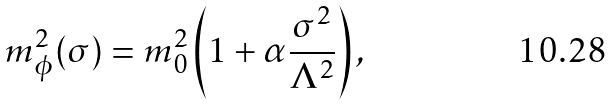<formula> <loc_0><loc_0><loc_500><loc_500>m ^ { 2 } _ { \phi } ( \sigma ) = m _ { 0 } ^ { 2 } \left ( 1 + \alpha \frac { \sigma ^ { 2 } } { \Lambda ^ { 2 } } \right ) ,</formula> 